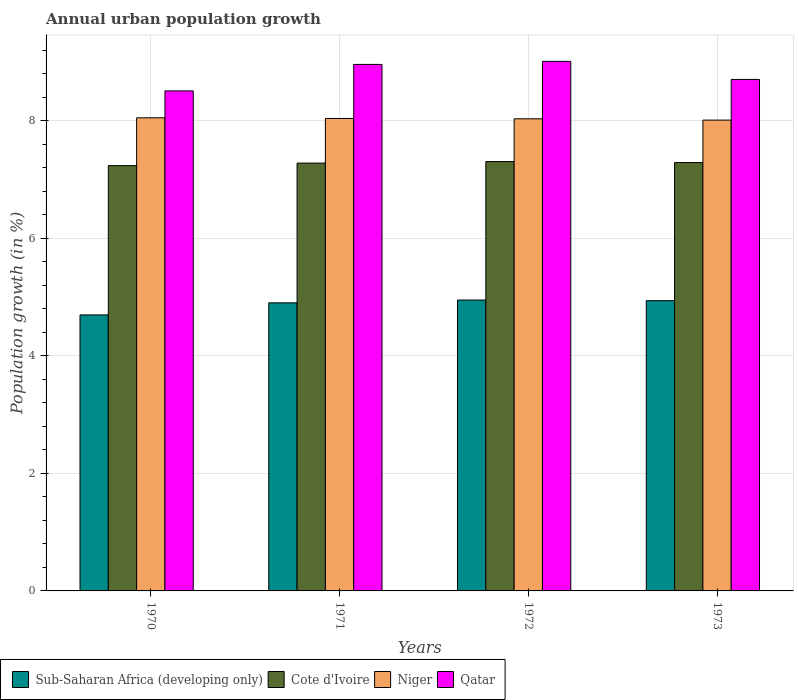How many groups of bars are there?
Your answer should be compact. 4. Are the number of bars per tick equal to the number of legend labels?
Your response must be concise. Yes. How many bars are there on the 4th tick from the right?
Your response must be concise. 4. What is the percentage of urban population growth in Cote d'Ivoire in 1973?
Offer a terse response. 7.29. Across all years, what is the maximum percentage of urban population growth in Qatar?
Provide a succinct answer. 9.01. Across all years, what is the minimum percentage of urban population growth in Niger?
Offer a very short reply. 8.01. In which year was the percentage of urban population growth in Sub-Saharan Africa (developing only) maximum?
Offer a terse response. 1972. What is the total percentage of urban population growth in Cote d'Ivoire in the graph?
Give a very brief answer. 29.12. What is the difference between the percentage of urban population growth in Sub-Saharan Africa (developing only) in 1971 and that in 1972?
Offer a very short reply. -0.05. What is the difference between the percentage of urban population growth in Niger in 1973 and the percentage of urban population growth in Cote d'Ivoire in 1972?
Ensure brevity in your answer.  0.71. What is the average percentage of urban population growth in Niger per year?
Offer a terse response. 8.03. In the year 1972, what is the difference between the percentage of urban population growth in Qatar and percentage of urban population growth in Sub-Saharan Africa (developing only)?
Make the answer very short. 4.06. What is the ratio of the percentage of urban population growth in Sub-Saharan Africa (developing only) in 1970 to that in 1973?
Your answer should be very brief. 0.95. Is the percentage of urban population growth in Qatar in 1971 less than that in 1973?
Give a very brief answer. No. What is the difference between the highest and the second highest percentage of urban population growth in Sub-Saharan Africa (developing only)?
Your answer should be compact. 0.01. What is the difference between the highest and the lowest percentage of urban population growth in Sub-Saharan Africa (developing only)?
Your answer should be very brief. 0.25. What does the 1st bar from the left in 1972 represents?
Ensure brevity in your answer.  Sub-Saharan Africa (developing only). What does the 4th bar from the right in 1973 represents?
Give a very brief answer. Sub-Saharan Africa (developing only). What is the difference between two consecutive major ticks on the Y-axis?
Give a very brief answer. 2. Are the values on the major ticks of Y-axis written in scientific E-notation?
Provide a succinct answer. No. Where does the legend appear in the graph?
Your answer should be compact. Bottom left. How are the legend labels stacked?
Your answer should be very brief. Horizontal. What is the title of the graph?
Provide a short and direct response. Annual urban population growth. Does "Costa Rica" appear as one of the legend labels in the graph?
Make the answer very short. No. What is the label or title of the Y-axis?
Provide a short and direct response. Population growth (in %). What is the Population growth (in %) of Sub-Saharan Africa (developing only) in 1970?
Offer a very short reply. 4.7. What is the Population growth (in %) of Cote d'Ivoire in 1970?
Your response must be concise. 7.24. What is the Population growth (in %) of Niger in 1970?
Keep it short and to the point. 8.05. What is the Population growth (in %) in Qatar in 1970?
Make the answer very short. 8.51. What is the Population growth (in %) in Sub-Saharan Africa (developing only) in 1971?
Offer a very short reply. 4.9. What is the Population growth (in %) of Cote d'Ivoire in 1971?
Your answer should be very brief. 7.28. What is the Population growth (in %) of Niger in 1971?
Make the answer very short. 8.04. What is the Population growth (in %) of Qatar in 1971?
Keep it short and to the point. 8.96. What is the Population growth (in %) in Sub-Saharan Africa (developing only) in 1972?
Keep it short and to the point. 4.95. What is the Population growth (in %) in Cote d'Ivoire in 1972?
Make the answer very short. 7.31. What is the Population growth (in %) in Niger in 1972?
Your answer should be very brief. 8.03. What is the Population growth (in %) in Qatar in 1972?
Keep it short and to the point. 9.01. What is the Population growth (in %) of Sub-Saharan Africa (developing only) in 1973?
Keep it short and to the point. 4.94. What is the Population growth (in %) in Cote d'Ivoire in 1973?
Give a very brief answer. 7.29. What is the Population growth (in %) in Niger in 1973?
Ensure brevity in your answer.  8.01. What is the Population growth (in %) in Qatar in 1973?
Your answer should be very brief. 8.7. Across all years, what is the maximum Population growth (in %) in Sub-Saharan Africa (developing only)?
Offer a terse response. 4.95. Across all years, what is the maximum Population growth (in %) in Cote d'Ivoire?
Offer a terse response. 7.31. Across all years, what is the maximum Population growth (in %) of Niger?
Provide a short and direct response. 8.05. Across all years, what is the maximum Population growth (in %) of Qatar?
Make the answer very short. 9.01. Across all years, what is the minimum Population growth (in %) of Sub-Saharan Africa (developing only)?
Provide a short and direct response. 4.7. Across all years, what is the minimum Population growth (in %) in Cote d'Ivoire?
Your response must be concise. 7.24. Across all years, what is the minimum Population growth (in %) of Niger?
Provide a succinct answer. 8.01. Across all years, what is the minimum Population growth (in %) in Qatar?
Ensure brevity in your answer.  8.51. What is the total Population growth (in %) in Sub-Saharan Africa (developing only) in the graph?
Your response must be concise. 19.49. What is the total Population growth (in %) of Cote d'Ivoire in the graph?
Offer a very short reply. 29.12. What is the total Population growth (in %) in Niger in the graph?
Make the answer very short. 32.14. What is the total Population growth (in %) in Qatar in the graph?
Make the answer very short. 35.19. What is the difference between the Population growth (in %) in Sub-Saharan Africa (developing only) in 1970 and that in 1971?
Keep it short and to the point. -0.21. What is the difference between the Population growth (in %) in Cote d'Ivoire in 1970 and that in 1971?
Keep it short and to the point. -0.04. What is the difference between the Population growth (in %) of Niger in 1970 and that in 1971?
Offer a very short reply. 0.01. What is the difference between the Population growth (in %) of Qatar in 1970 and that in 1971?
Your response must be concise. -0.45. What is the difference between the Population growth (in %) in Sub-Saharan Africa (developing only) in 1970 and that in 1972?
Give a very brief answer. -0.25. What is the difference between the Population growth (in %) in Cote d'Ivoire in 1970 and that in 1972?
Offer a terse response. -0.07. What is the difference between the Population growth (in %) in Niger in 1970 and that in 1972?
Offer a very short reply. 0.02. What is the difference between the Population growth (in %) in Qatar in 1970 and that in 1972?
Ensure brevity in your answer.  -0.5. What is the difference between the Population growth (in %) of Sub-Saharan Africa (developing only) in 1970 and that in 1973?
Offer a terse response. -0.24. What is the difference between the Population growth (in %) in Cote d'Ivoire in 1970 and that in 1973?
Your response must be concise. -0.05. What is the difference between the Population growth (in %) of Niger in 1970 and that in 1973?
Offer a very short reply. 0.04. What is the difference between the Population growth (in %) of Qatar in 1970 and that in 1973?
Offer a very short reply. -0.2. What is the difference between the Population growth (in %) in Sub-Saharan Africa (developing only) in 1971 and that in 1972?
Your answer should be very brief. -0.05. What is the difference between the Population growth (in %) in Cote d'Ivoire in 1971 and that in 1972?
Make the answer very short. -0.03. What is the difference between the Population growth (in %) in Niger in 1971 and that in 1972?
Make the answer very short. 0.01. What is the difference between the Population growth (in %) in Qatar in 1971 and that in 1972?
Ensure brevity in your answer.  -0.05. What is the difference between the Population growth (in %) in Sub-Saharan Africa (developing only) in 1971 and that in 1973?
Your answer should be very brief. -0.04. What is the difference between the Population growth (in %) in Cote d'Ivoire in 1971 and that in 1973?
Your answer should be compact. -0.01. What is the difference between the Population growth (in %) in Niger in 1971 and that in 1973?
Offer a very short reply. 0.03. What is the difference between the Population growth (in %) of Qatar in 1971 and that in 1973?
Your answer should be very brief. 0.26. What is the difference between the Population growth (in %) in Sub-Saharan Africa (developing only) in 1972 and that in 1973?
Your response must be concise. 0.01. What is the difference between the Population growth (in %) of Cote d'Ivoire in 1972 and that in 1973?
Give a very brief answer. 0.02. What is the difference between the Population growth (in %) in Niger in 1972 and that in 1973?
Offer a very short reply. 0.02. What is the difference between the Population growth (in %) in Qatar in 1972 and that in 1973?
Offer a very short reply. 0.31. What is the difference between the Population growth (in %) of Sub-Saharan Africa (developing only) in 1970 and the Population growth (in %) of Cote d'Ivoire in 1971?
Your answer should be compact. -2.58. What is the difference between the Population growth (in %) of Sub-Saharan Africa (developing only) in 1970 and the Population growth (in %) of Niger in 1971?
Offer a very short reply. -3.34. What is the difference between the Population growth (in %) of Sub-Saharan Africa (developing only) in 1970 and the Population growth (in %) of Qatar in 1971?
Your answer should be very brief. -4.26. What is the difference between the Population growth (in %) in Cote d'Ivoire in 1970 and the Population growth (in %) in Niger in 1971?
Your answer should be compact. -0.8. What is the difference between the Population growth (in %) in Cote d'Ivoire in 1970 and the Population growth (in %) in Qatar in 1971?
Offer a terse response. -1.72. What is the difference between the Population growth (in %) of Niger in 1970 and the Population growth (in %) of Qatar in 1971?
Keep it short and to the point. -0.91. What is the difference between the Population growth (in %) in Sub-Saharan Africa (developing only) in 1970 and the Population growth (in %) in Cote d'Ivoire in 1972?
Provide a short and direct response. -2.61. What is the difference between the Population growth (in %) in Sub-Saharan Africa (developing only) in 1970 and the Population growth (in %) in Niger in 1972?
Keep it short and to the point. -3.34. What is the difference between the Population growth (in %) in Sub-Saharan Africa (developing only) in 1970 and the Population growth (in %) in Qatar in 1972?
Provide a succinct answer. -4.32. What is the difference between the Population growth (in %) in Cote d'Ivoire in 1970 and the Population growth (in %) in Niger in 1972?
Your response must be concise. -0.8. What is the difference between the Population growth (in %) in Cote d'Ivoire in 1970 and the Population growth (in %) in Qatar in 1972?
Make the answer very short. -1.77. What is the difference between the Population growth (in %) of Niger in 1970 and the Population growth (in %) of Qatar in 1972?
Provide a succinct answer. -0.96. What is the difference between the Population growth (in %) in Sub-Saharan Africa (developing only) in 1970 and the Population growth (in %) in Cote d'Ivoire in 1973?
Your answer should be very brief. -2.59. What is the difference between the Population growth (in %) of Sub-Saharan Africa (developing only) in 1970 and the Population growth (in %) of Niger in 1973?
Your response must be concise. -3.32. What is the difference between the Population growth (in %) of Sub-Saharan Africa (developing only) in 1970 and the Population growth (in %) of Qatar in 1973?
Offer a very short reply. -4.01. What is the difference between the Population growth (in %) in Cote d'Ivoire in 1970 and the Population growth (in %) in Niger in 1973?
Keep it short and to the point. -0.77. What is the difference between the Population growth (in %) of Cote d'Ivoire in 1970 and the Population growth (in %) of Qatar in 1973?
Keep it short and to the point. -1.47. What is the difference between the Population growth (in %) of Niger in 1970 and the Population growth (in %) of Qatar in 1973?
Your answer should be compact. -0.65. What is the difference between the Population growth (in %) in Sub-Saharan Africa (developing only) in 1971 and the Population growth (in %) in Cote d'Ivoire in 1972?
Keep it short and to the point. -2.4. What is the difference between the Population growth (in %) of Sub-Saharan Africa (developing only) in 1971 and the Population growth (in %) of Niger in 1972?
Give a very brief answer. -3.13. What is the difference between the Population growth (in %) in Sub-Saharan Africa (developing only) in 1971 and the Population growth (in %) in Qatar in 1972?
Make the answer very short. -4.11. What is the difference between the Population growth (in %) of Cote d'Ivoire in 1971 and the Population growth (in %) of Niger in 1972?
Provide a short and direct response. -0.75. What is the difference between the Population growth (in %) of Cote d'Ivoire in 1971 and the Population growth (in %) of Qatar in 1972?
Keep it short and to the point. -1.73. What is the difference between the Population growth (in %) of Niger in 1971 and the Population growth (in %) of Qatar in 1972?
Make the answer very short. -0.97. What is the difference between the Population growth (in %) of Sub-Saharan Africa (developing only) in 1971 and the Population growth (in %) of Cote d'Ivoire in 1973?
Offer a terse response. -2.39. What is the difference between the Population growth (in %) in Sub-Saharan Africa (developing only) in 1971 and the Population growth (in %) in Niger in 1973?
Offer a very short reply. -3.11. What is the difference between the Population growth (in %) of Sub-Saharan Africa (developing only) in 1971 and the Population growth (in %) of Qatar in 1973?
Make the answer very short. -3.8. What is the difference between the Population growth (in %) in Cote d'Ivoire in 1971 and the Population growth (in %) in Niger in 1973?
Your response must be concise. -0.73. What is the difference between the Population growth (in %) in Cote d'Ivoire in 1971 and the Population growth (in %) in Qatar in 1973?
Offer a terse response. -1.42. What is the difference between the Population growth (in %) in Niger in 1971 and the Population growth (in %) in Qatar in 1973?
Ensure brevity in your answer.  -0.66. What is the difference between the Population growth (in %) in Sub-Saharan Africa (developing only) in 1972 and the Population growth (in %) in Cote d'Ivoire in 1973?
Provide a short and direct response. -2.34. What is the difference between the Population growth (in %) in Sub-Saharan Africa (developing only) in 1972 and the Population growth (in %) in Niger in 1973?
Keep it short and to the point. -3.06. What is the difference between the Population growth (in %) of Sub-Saharan Africa (developing only) in 1972 and the Population growth (in %) of Qatar in 1973?
Your response must be concise. -3.75. What is the difference between the Population growth (in %) in Cote d'Ivoire in 1972 and the Population growth (in %) in Niger in 1973?
Offer a terse response. -0.71. What is the difference between the Population growth (in %) in Cote d'Ivoire in 1972 and the Population growth (in %) in Qatar in 1973?
Provide a short and direct response. -1.4. What is the difference between the Population growth (in %) in Niger in 1972 and the Population growth (in %) in Qatar in 1973?
Your response must be concise. -0.67. What is the average Population growth (in %) in Sub-Saharan Africa (developing only) per year?
Your answer should be very brief. 4.87. What is the average Population growth (in %) of Cote d'Ivoire per year?
Ensure brevity in your answer.  7.28. What is the average Population growth (in %) in Niger per year?
Ensure brevity in your answer.  8.03. What is the average Population growth (in %) of Qatar per year?
Provide a short and direct response. 8.8. In the year 1970, what is the difference between the Population growth (in %) of Sub-Saharan Africa (developing only) and Population growth (in %) of Cote d'Ivoire?
Offer a very short reply. -2.54. In the year 1970, what is the difference between the Population growth (in %) in Sub-Saharan Africa (developing only) and Population growth (in %) in Niger?
Provide a succinct answer. -3.35. In the year 1970, what is the difference between the Population growth (in %) of Sub-Saharan Africa (developing only) and Population growth (in %) of Qatar?
Provide a short and direct response. -3.81. In the year 1970, what is the difference between the Population growth (in %) in Cote d'Ivoire and Population growth (in %) in Niger?
Keep it short and to the point. -0.81. In the year 1970, what is the difference between the Population growth (in %) of Cote d'Ivoire and Population growth (in %) of Qatar?
Offer a terse response. -1.27. In the year 1970, what is the difference between the Population growth (in %) of Niger and Population growth (in %) of Qatar?
Ensure brevity in your answer.  -0.46. In the year 1971, what is the difference between the Population growth (in %) in Sub-Saharan Africa (developing only) and Population growth (in %) in Cote d'Ivoire?
Your answer should be compact. -2.38. In the year 1971, what is the difference between the Population growth (in %) in Sub-Saharan Africa (developing only) and Population growth (in %) in Niger?
Give a very brief answer. -3.14. In the year 1971, what is the difference between the Population growth (in %) in Sub-Saharan Africa (developing only) and Population growth (in %) in Qatar?
Your answer should be very brief. -4.06. In the year 1971, what is the difference between the Population growth (in %) of Cote d'Ivoire and Population growth (in %) of Niger?
Offer a terse response. -0.76. In the year 1971, what is the difference between the Population growth (in %) of Cote d'Ivoire and Population growth (in %) of Qatar?
Offer a terse response. -1.68. In the year 1971, what is the difference between the Population growth (in %) of Niger and Population growth (in %) of Qatar?
Keep it short and to the point. -0.92. In the year 1972, what is the difference between the Population growth (in %) of Sub-Saharan Africa (developing only) and Population growth (in %) of Cote d'Ivoire?
Provide a succinct answer. -2.36. In the year 1972, what is the difference between the Population growth (in %) in Sub-Saharan Africa (developing only) and Population growth (in %) in Niger?
Give a very brief answer. -3.08. In the year 1972, what is the difference between the Population growth (in %) in Sub-Saharan Africa (developing only) and Population growth (in %) in Qatar?
Offer a very short reply. -4.06. In the year 1972, what is the difference between the Population growth (in %) of Cote d'Ivoire and Population growth (in %) of Niger?
Ensure brevity in your answer.  -0.73. In the year 1972, what is the difference between the Population growth (in %) of Cote d'Ivoire and Population growth (in %) of Qatar?
Make the answer very short. -1.71. In the year 1972, what is the difference between the Population growth (in %) in Niger and Population growth (in %) in Qatar?
Your answer should be compact. -0.98. In the year 1973, what is the difference between the Population growth (in %) in Sub-Saharan Africa (developing only) and Population growth (in %) in Cote d'Ivoire?
Your answer should be very brief. -2.35. In the year 1973, what is the difference between the Population growth (in %) in Sub-Saharan Africa (developing only) and Population growth (in %) in Niger?
Keep it short and to the point. -3.07. In the year 1973, what is the difference between the Population growth (in %) in Sub-Saharan Africa (developing only) and Population growth (in %) in Qatar?
Your answer should be very brief. -3.76. In the year 1973, what is the difference between the Population growth (in %) of Cote d'Ivoire and Population growth (in %) of Niger?
Provide a short and direct response. -0.72. In the year 1973, what is the difference between the Population growth (in %) of Cote d'Ivoire and Population growth (in %) of Qatar?
Your answer should be very brief. -1.41. In the year 1973, what is the difference between the Population growth (in %) in Niger and Population growth (in %) in Qatar?
Your response must be concise. -0.69. What is the ratio of the Population growth (in %) in Sub-Saharan Africa (developing only) in 1970 to that in 1971?
Make the answer very short. 0.96. What is the ratio of the Population growth (in %) in Cote d'Ivoire in 1970 to that in 1971?
Your response must be concise. 0.99. What is the ratio of the Population growth (in %) of Niger in 1970 to that in 1971?
Give a very brief answer. 1. What is the ratio of the Population growth (in %) of Qatar in 1970 to that in 1971?
Your response must be concise. 0.95. What is the ratio of the Population growth (in %) of Sub-Saharan Africa (developing only) in 1970 to that in 1972?
Make the answer very short. 0.95. What is the ratio of the Population growth (in %) in Cote d'Ivoire in 1970 to that in 1972?
Your response must be concise. 0.99. What is the ratio of the Population growth (in %) of Niger in 1970 to that in 1972?
Your answer should be very brief. 1. What is the ratio of the Population growth (in %) in Qatar in 1970 to that in 1972?
Keep it short and to the point. 0.94. What is the ratio of the Population growth (in %) in Sub-Saharan Africa (developing only) in 1970 to that in 1973?
Your response must be concise. 0.95. What is the ratio of the Population growth (in %) of Niger in 1970 to that in 1973?
Your response must be concise. 1. What is the ratio of the Population growth (in %) of Qatar in 1970 to that in 1973?
Your response must be concise. 0.98. What is the ratio of the Population growth (in %) in Sub-Saharan Africa (developing only) in 1971 to that in 1972?
Your response must be concise. 0.99. What is the ratio of the Population growth (in %) in Qatar in 1971 to that in 1972?
Make the answer very short. 0.99. What is the ratio of the Population growth (in %) of Sub-Saharan Africa (developing only) in 1971 to that in 1973?
Keep it short and to the point. 0.99. What is the ratio of the Population growth (in %) of Niger in 1971 to that in 1973?
Keep it short and to the point. 1. What is the ratio of the Population growth (in %) of Qatar in 1971 to that in 1973?
Your response must be concise. 1.03. What is the ratio of the Population growth (in %) of Sub-Saharan Africa (developing only) in 1972 to that in 1973?
Ensure brevity in your answer.  1. What is the ratio of the Population growth (in %) of Cote d'Ivoire in 1972 to that in 1973?
Your answer should be compact. 1. What is the ratio of the Population growth (in %) of Niger in 1972 to that in 1973?
Offer a terse response. 1. What is the ratio of the Population growth (in %) in Qatar in 1972 to that in 1973?
Offer a terse response. 1.04. What is the difference between the highest and the second highest Population growth (in %) of Sub-Saharan Africa (developing only)?
Your answer should be very brief. 0.01. What is the difference between the highest and the second highest Population growth (in %) of Cote d'Ivoire?
Give a very brief answer. 0.02. What is the difference between the highest and the second highest Population growth (in %) of Niger?
Your response must be concise. 0.01. What is the difference between the highest and the second highest Population growth (in %) of Qatar?
Provide a succinct answer. 0.05. What is the difference between the highest and the lowest Population growth (in %) of Sub-Saharan Africa (developing only)?
Provide a succinct answer. 0.25. What is the difference between the highest and the lowest Population growth (in %) of Cote d'Ivoire?
Provide a short and direct response. 0.07. What is the difference between the highest and the lowest Population growth (in %) in Niger?
Make the answer very short. 0.04. What is the difference between the highest and the lowest Population growth (in %) of Qatar?
Ensure brevity in your answer.  0.5. 